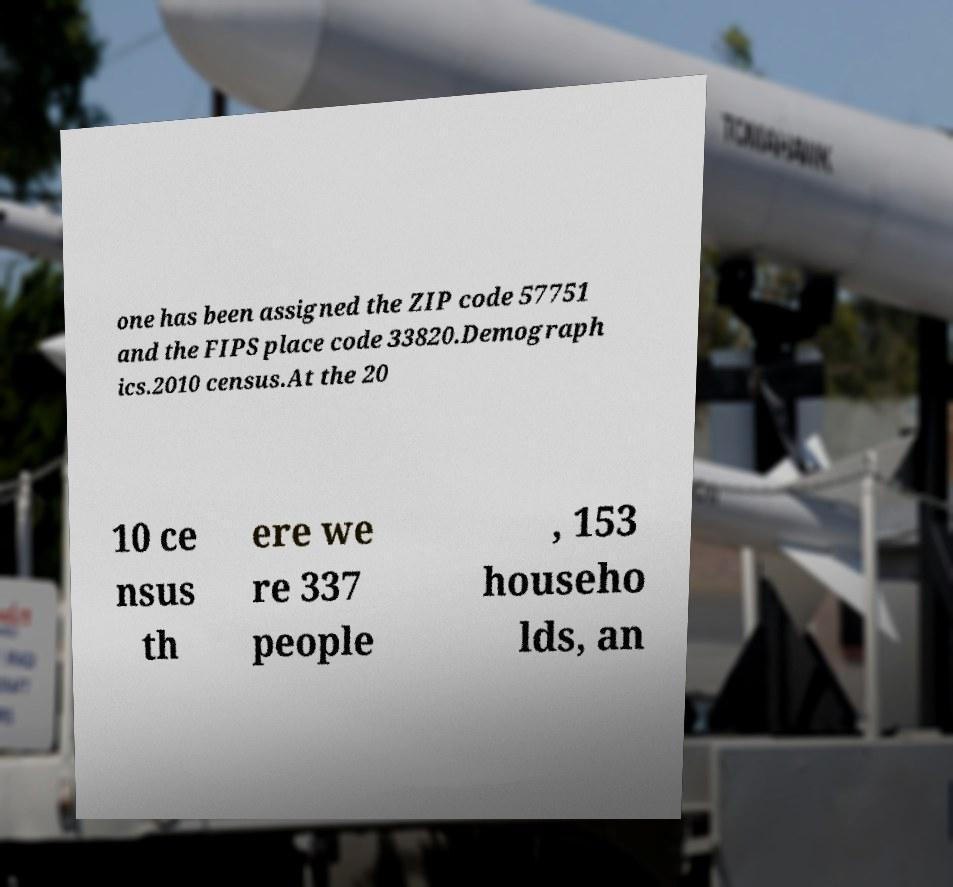Can you accurately transcribe the text from the provided image for me? one has been assigned the ZIP code 57751 and the FIPS place code 33820.Demograph ics.2010 census.At the 20 10 ce nsus th ere we re 337 people , 153 househo lds, an 